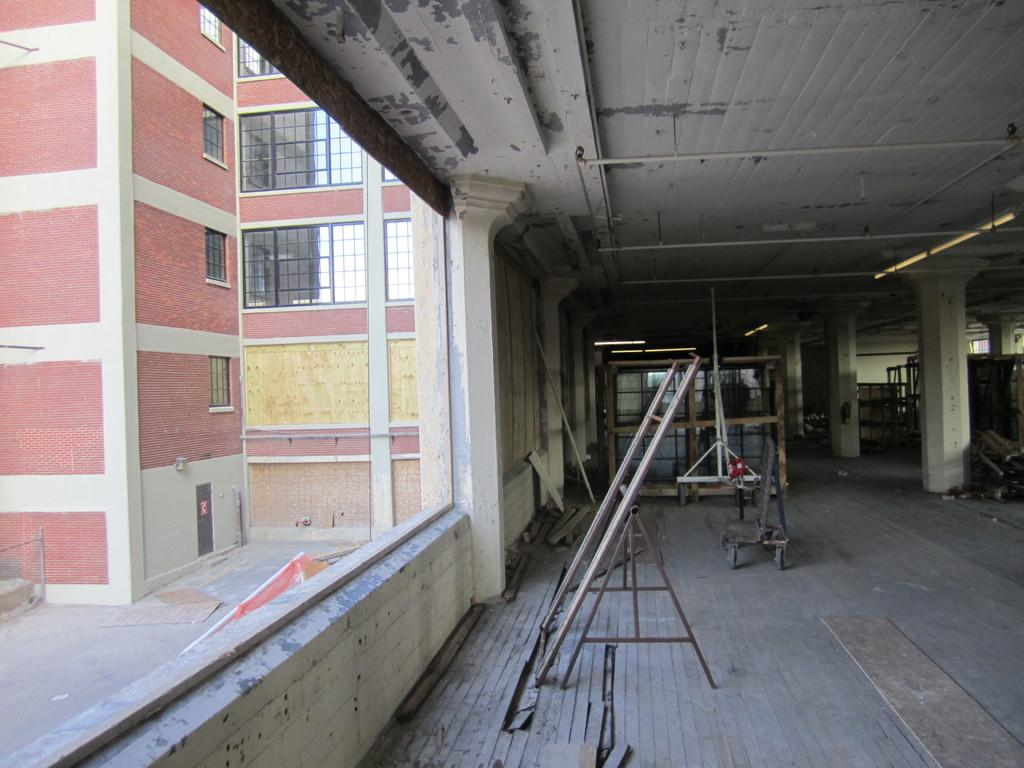What is the main subject of the image? There is a building under construction in the image. Are there any other buildings visible in the image? Yes, there are other buildings visible in the image. What type of whip is being used to control the pigs in the image? There are no pigs or whips present in the image; it features a building under construction and other buildings. 